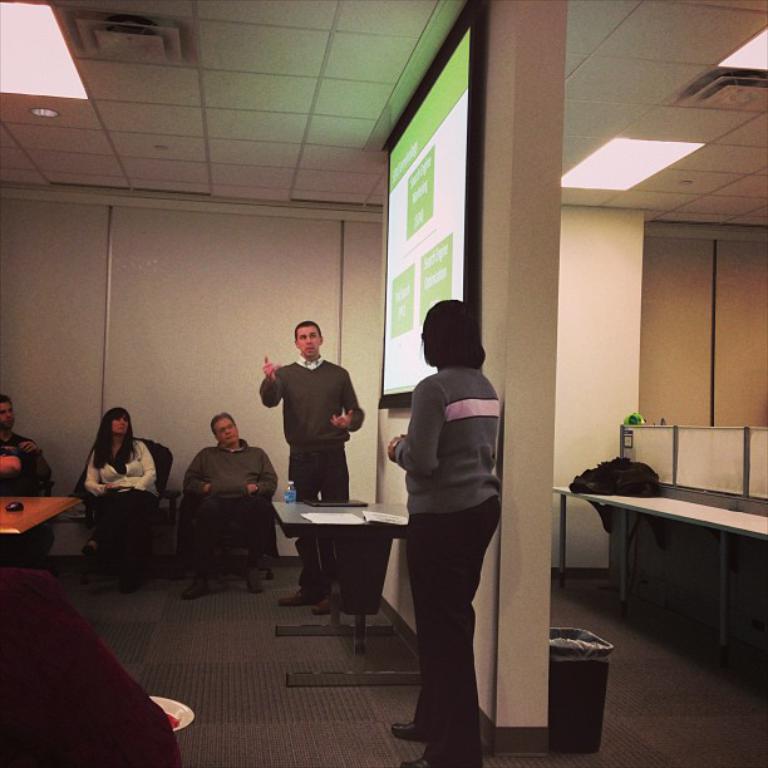In one or two sentences, can you explain what this image depicts? There is a room. On the right side we have women. She is standing. On the left side we have a person's. They are sitting in a chair. In the center we have a person he is standing his explain. Remaining all are listening to him. There is a table. There is a bottle,paper on a table. We can see in the background there is a light,projector and bag on a desk. 